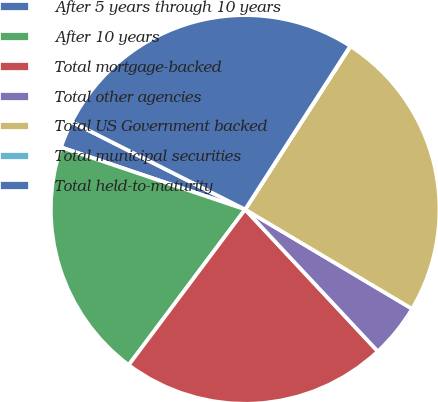Convert chart to OTSL. <chart><loc_0><loc_0><loc_500><loc_500><pie_chart><fcel>After 5 years through 10 years<fcel>After 10 years<fcel>Total mortgage-backed<fcel>Total other agencies<fcel>Total US Government backed<fcel>Total municipal securities<fcel>Total held-to-maturity<nl><fcel>2.26%<fcel>19.96%<fcel>22.19%<fcel>4.49%<fcel>24.42%<fcel>0.03%<fcel>26.65%<nl></chart> 